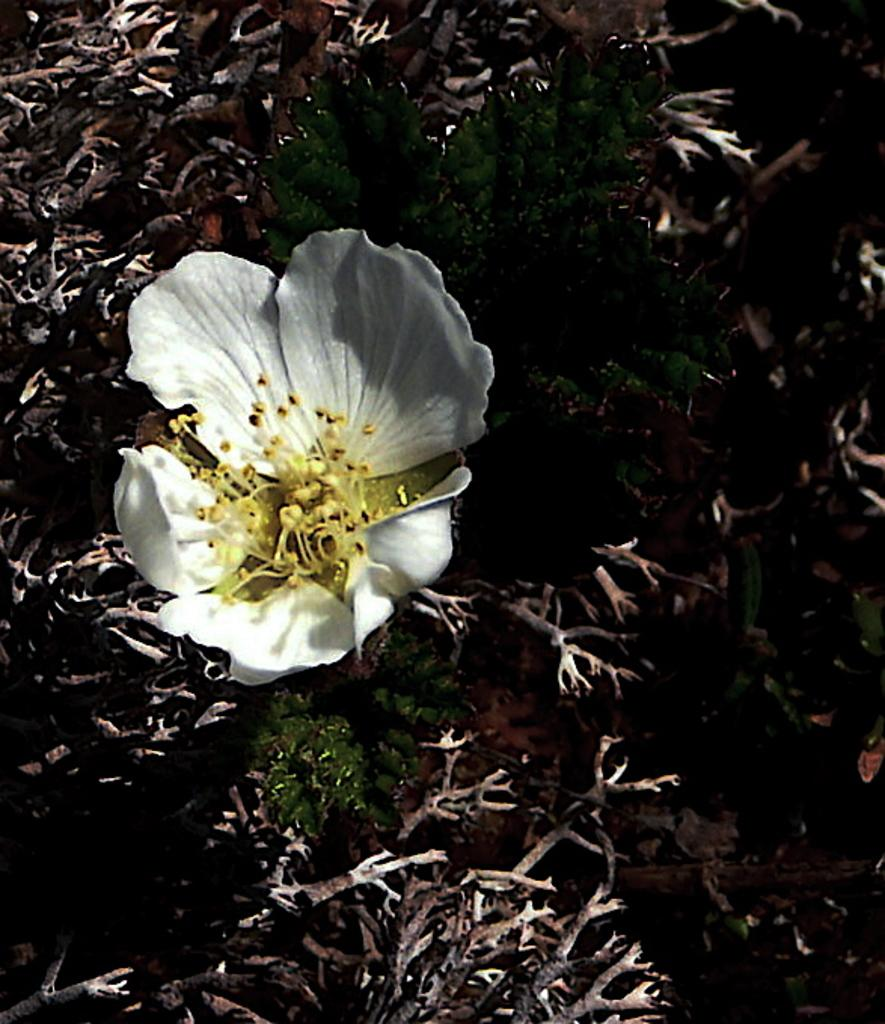What type of flower is present in the image? There is a white color flower in the image. Can you describe the plant that the flower is a part of? The flower's plant is visible in the image. What else can be seen in the image related to the plant? There are dried stems and leaves in the image. What type of milk is being used for the camp reading activity in the image? There is no milk, camp, or reading activity present in the image. 